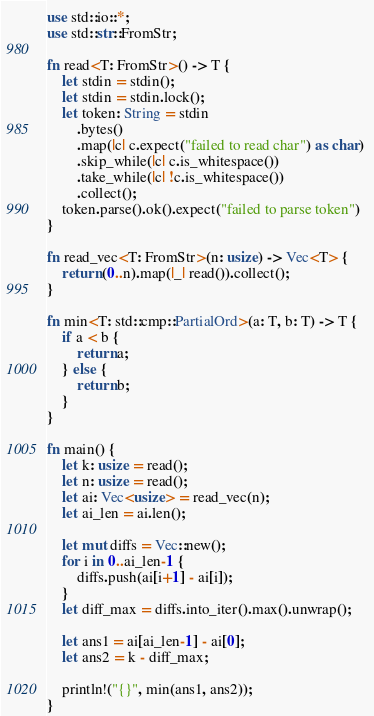Convert code to text. <code><loc_0><loc_0><loc_500><loc_500><_Rust_>use std::io::*;
use std::str::FromStr;

fn read<T: FromStr>() -> T {
    let stdin = stdin();
    let stdin = stdin.lock();
    let token: String = stdin
        .bytes()
        .map(|c| c.expect("failed to read char") as char) 
        .skip_while(|c| c.is_whitespace())
        .take_while(|c| !c.is_whitespace())
        .collect();
    token.parse().ok().expect("failed to parse token")
}

fn read_vec<T: FromStr>(n: usize) -> Vec<T> {
    return (0..n).map(|_| read()).collect();
}

fn min<T: std::cmp::PartialOrd>(a: T, b: T) -> T {
    if a < b {
        return a;
    } else {
        return b;
    }
}

fn main() {
    let k: usize = read();
    let n: usize = read();
    let ai: Vec<usize> = read_vec(n);
    let ai_len = ai.len();

    let mut diffs = Vec::new();
    for i in 0..ai_len-1 {
        diffs.push(ai[i+1] - ai[i]);
    }
    let diff_max = diffs.into_iter().max().unwrap();

    let ans1 = ai[ai_len-1] - ai[0];
    let ans2 = k - diff_max;

    println!("{}", min(ans1, ans2));
}
</code> 